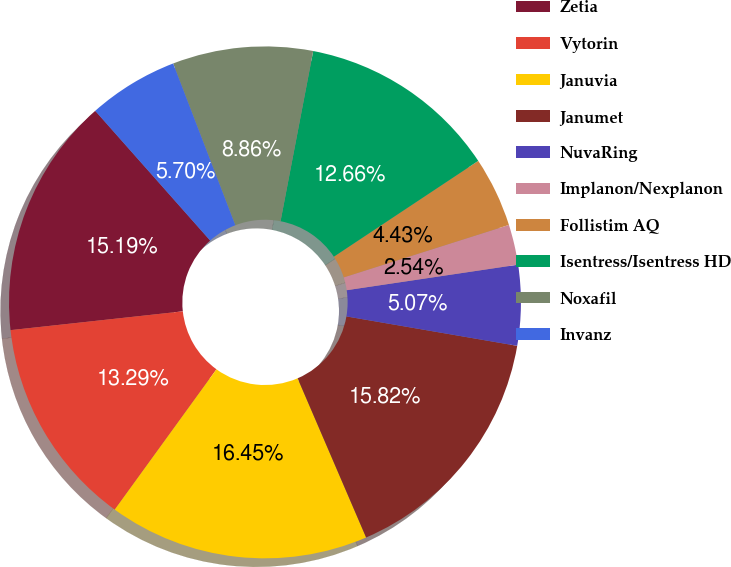Convert chart to OTSL. <chart><loc_0><loc_0><loc_500><loc_500><pie_chart><fcel>Zetia<fcel>Vytorin<fcel>Januvia<fcel>Janumet<fcel>NuvaRing<fcel>Implanon/Nexplanon<fcel>Follistim AQ<fcel>Isentress/Isentress HD<fcel>Noxafil<fcel>Invanz<nl><fcel>15.19%<fcel>13.29%<fcel>16.45%<fcel>15.82%<fcel>5.07%<fcel>2.54%<fcel>4.43%<fcel>12.66%<fcel>8.86%<fcel>5.7%<nl></chart> 